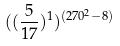<formula> <loc_0><loc_0><loc_500><loc_500>( ( \frac { 5 } { 1 7 } ) ^ { 1 } ) ^ { ( 2 7 0 ^ { 2 } - 8 ) }</formula> 